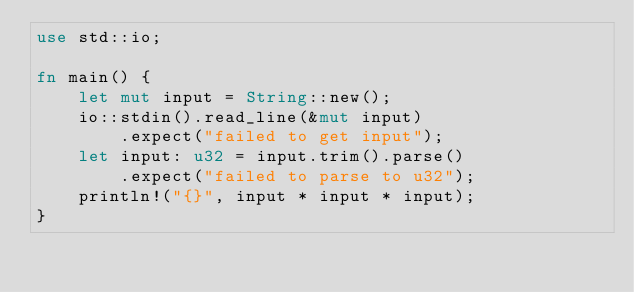Convert code to text. <code><loc_0><loc_0><loc_500><loc_500><_Rust_>use std::io;

fn main() {
    let mut input = String::new();
    io::stdin().read_line(&mut input)
        .expect("failed to get input");
    let input: u32 = input.trim().parse()
        .expect("failed to parse to u32");
    println!("{}", input * input * input);
}
</code> 